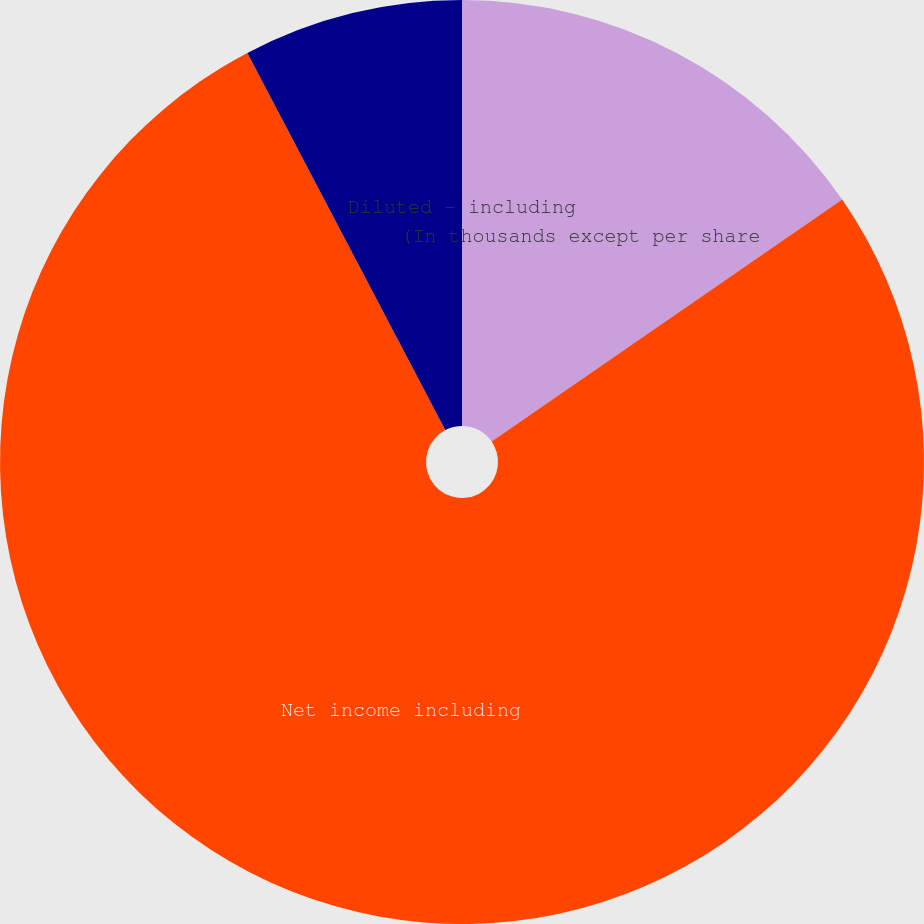<chart> <loc_0><loc_0><loc_500><loc_500><pie_chart><fcel>(In thousands except per share<fcel>Net income including<fcel>Basic - including share-based<fcel>Diluted - including<nl><fcel>15.38%<fcel>76.92%<fcel>7.69%<fcel>0.0%<nl></chart> 